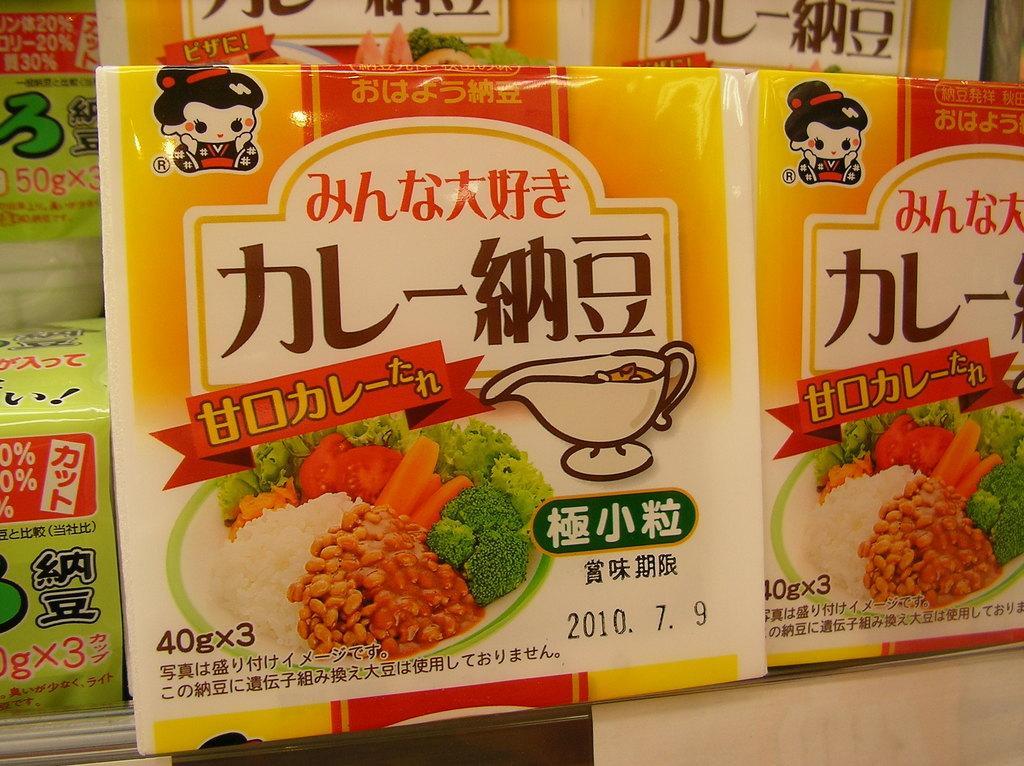In one or two sentences, can you explain what this image depicts? In this image we can see the packets with the text, date, weight and also the images. 